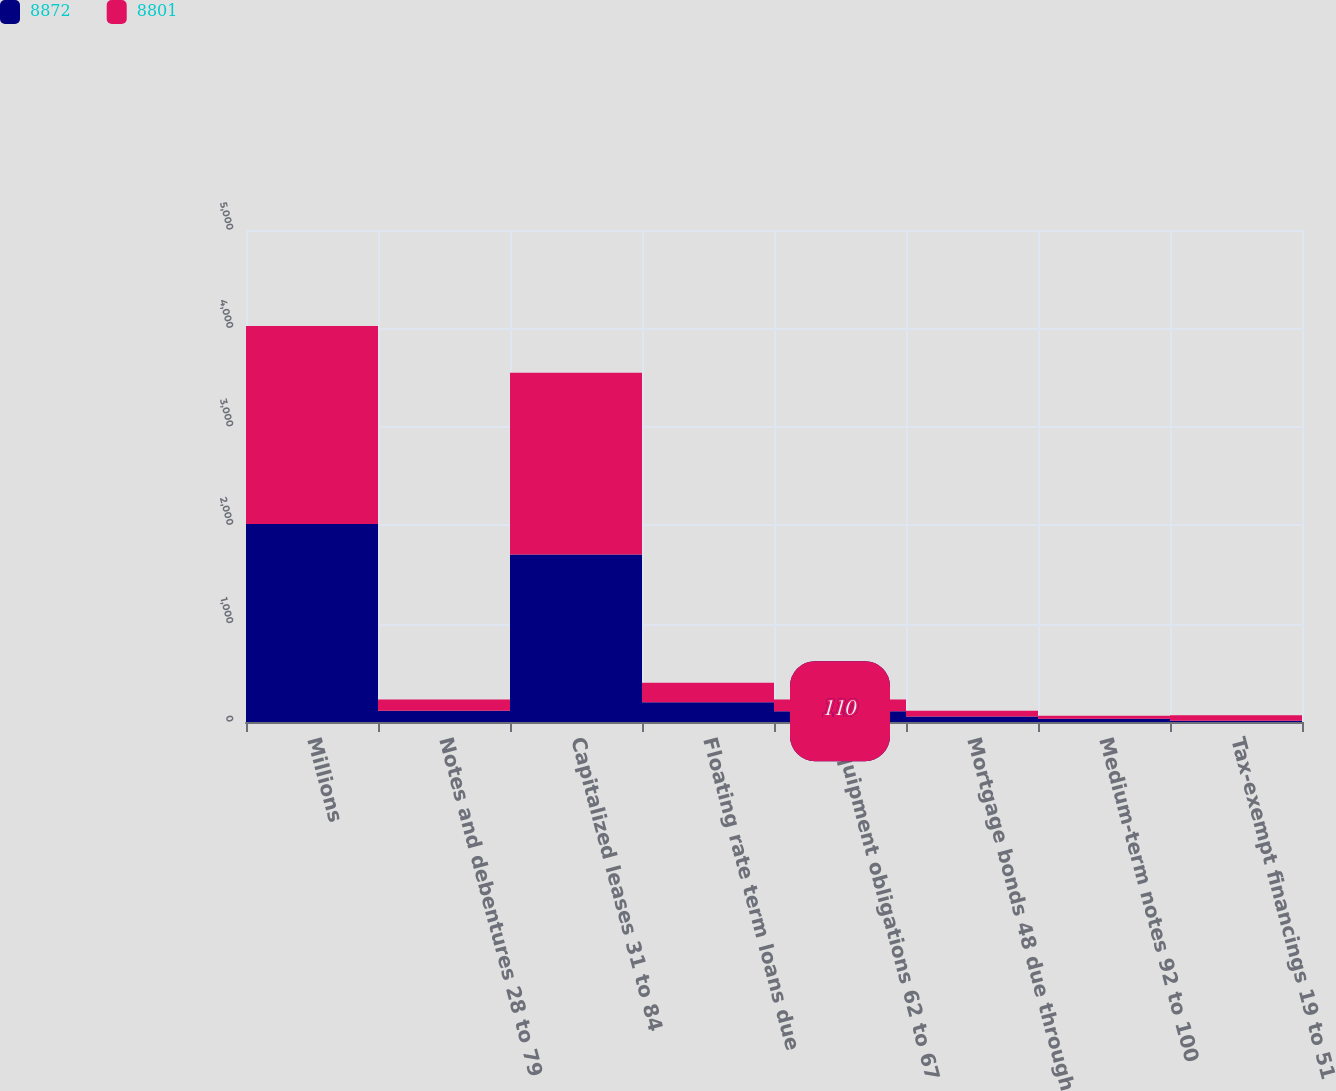Convert chart to OTSL. <chart><loc_0><loc_0><loc_500><loc_500><stacked_bar_chart><ecel><fcel>Millions<fcel>Notes and debentures 28 to 79<fcel>Capitalized leases 31 to 84<fcel>Floating rate term loans due<fcel>Equipment obligations 62 to 67<fcel>Mortgage bonds 48 due through<fcel>Medium-term notes 92 to 100<fcel>Tax-exempt financings 19 to 51<nl><fcel>8872<fcel>2013<fcel>114.5<fcel>1702<fcel>200<fcel>110<fcel>57<fcel>32<fcel>12<nl><fcel>8801<fcel>2012<fcel>114.5<fcel>1848<fcel>200<fcel>119<fcel>57<fcel>32<fcel>56<nl></chart> 